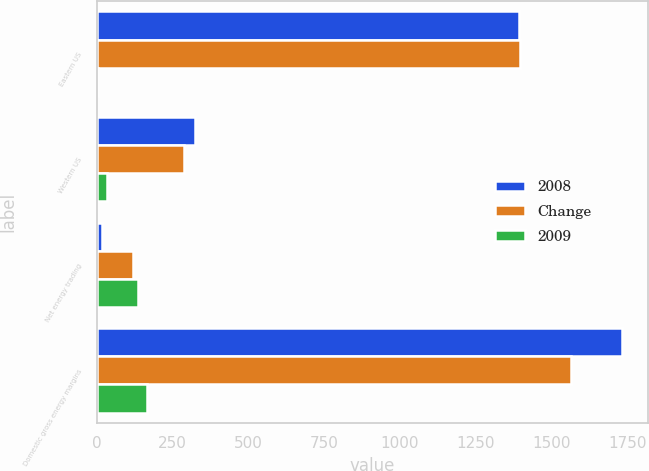<chart> <loc_0><loc_0><loc_500><loc_500><stacked_bar_chart><ecel><fcel>Eastern US<fcel>Western US<fcel>Net energy trading<fcel>Domestic gross energy margins<nl><fcel>2008<fcel>1391<fcel>323<fcel>17<fcel>1731<nl><fcel>Change<fcel>1396<fcel>289<fcel>121<fcel>1564<nl><fcel>2009<fcel>5<fcel>34<fcel>138<fcel>167<nl></chart> 